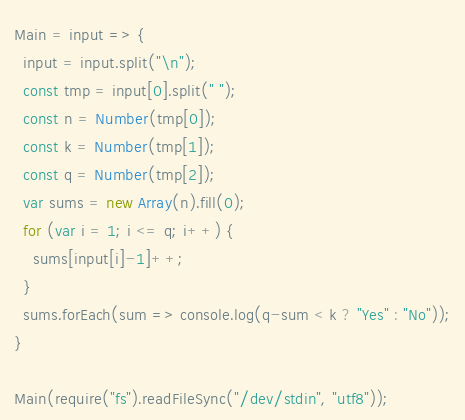Convert code to text. <code><loc_0><loc_0><loc_500><loc_500><_JavaScript_>Main = input => {
  input = input.split("\n");
  const tmp = input[0].split(" ");
  const n = Number(tmp[0]);
  const k = Number(tmp[1]);
  const q = Number(tmp[2]);
  var sums = new Array(n).fill(0);
  for (var i = 1; i <= q; i++) {
    sums[input[i]-1]++;
  }
  sums.forEach(sum => console.log(q-sum < k ? "Yes" : "No"));
}

Main(require("fs").readFileSync("/dev/stdin", "utf8"));</code> 